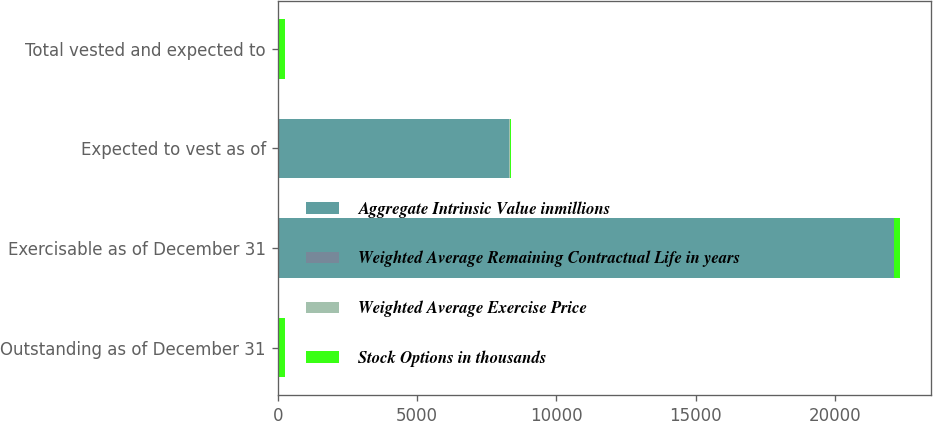Convert chart. <chart><loc_0><loc_0><loc_500><loc_500><stacked_bar_chart><ecel><fcel>Outstanding as of December 31<fcel>Exercisable as of December 31<fcel>Expected to vest as of<fcel>Total vested and expected to<nl><fcel>Aggregate Intrinsic Value inmillions<fcel>12<fcel>22104<fcel>8299<fcel>12<nl><fcel>Weighted Average Remaining Contractual Life in years<fcel>11<fcel>10<fcel>13<fcel>11<nl><fcel>Weighted Average Exercise Price<fcel>5.3<fcel>4<fcel>8.4<fcel>5.2<nl><fcel>Stock Options in thousands<fcel>240<fcel>196<fcel>42<fcel>238<nl></chart> 